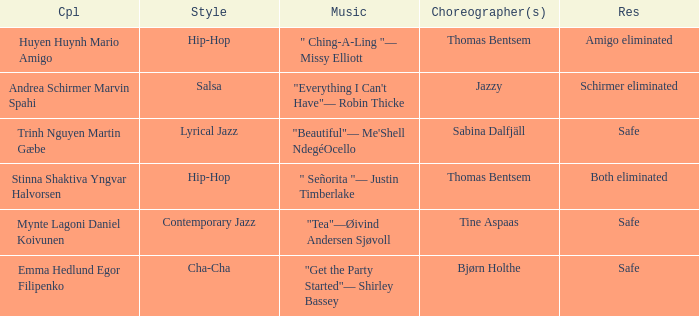What couple had a safe result and a lyrical jazz style? Trinh Nguyen Martin Gæbe. Could you parse the entire table as a dict? {'header': ['Cpl', 'Style', 'Music', 'Choreographer(s)', 'Res'], 'rows': [['Huyen Huynh Mario Amigo', 'Hip-Hop', '" Ching-A-Ling "— Missy Elliott', 'Thomas Bentsem', 'Amigo eliminated'], ['Andrea Schirmer Marvin Spahi', 'Salsa', '"Everything I Can\'t Have"— Robin Thicke', 'Jazzy', 'Schirmer eliminated'], ['Trinh Nguyen Martin Gæbe', 'Lyrical Jazz', '"Beautiful"— Me\'Shell NdegéOcello', 'Sabina Dalfjäll', 'Safe'], ['Stinna Shaktiva Yngvar Halvorsen', 'Hip-Hop', '" Señorita "— Justin Timberlake', 'Thomas Bentsem', 'Both eliminated'], ['Mynte Lagoni Daniel Koivunen', 'Contemporary Jazz', '"Tea"—Øivind Andersen Sjøvoll', 'Tine Aspaas', 'Safe'], ['Emma Hedlund Egor Filipenko', 'Cha-Cha', '"Get the Party Started"— Shirley Bassey', 'Bjørn Holthe', 'Safe']]} 